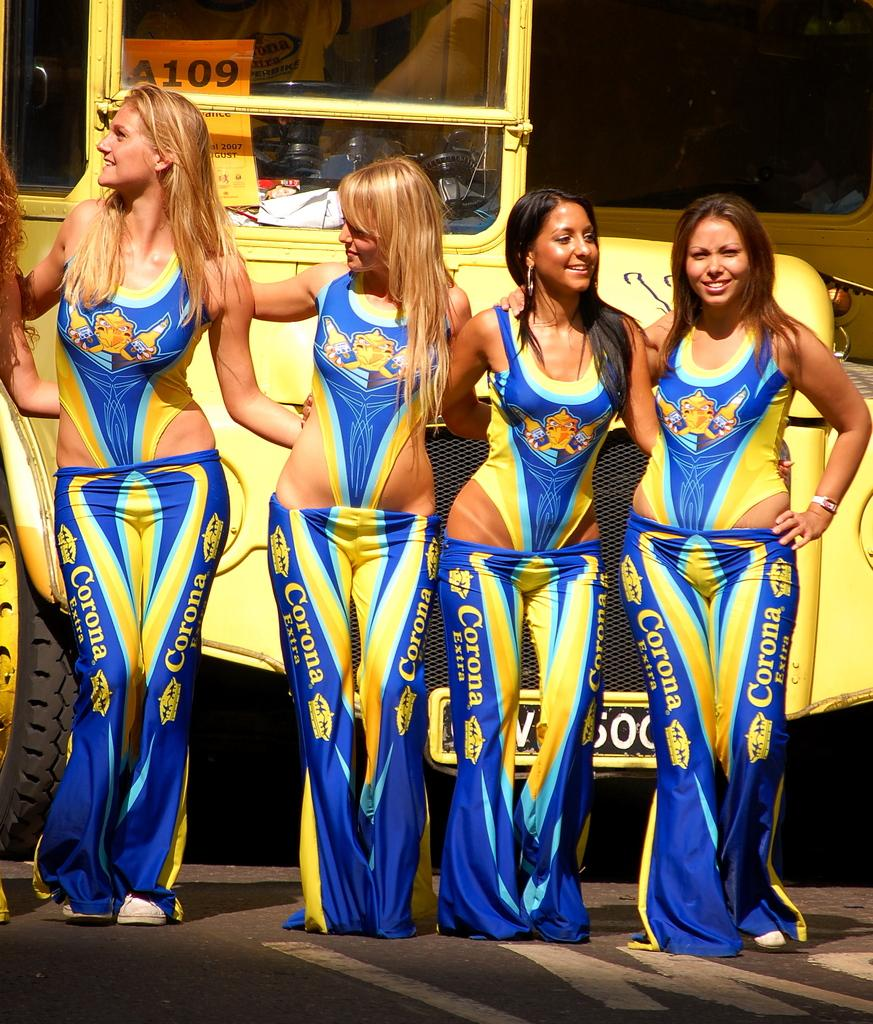<image>
Create a compact narrative representing the image presented. Women wearing Corona Extra leggings stand in front of a large yellow truck. 